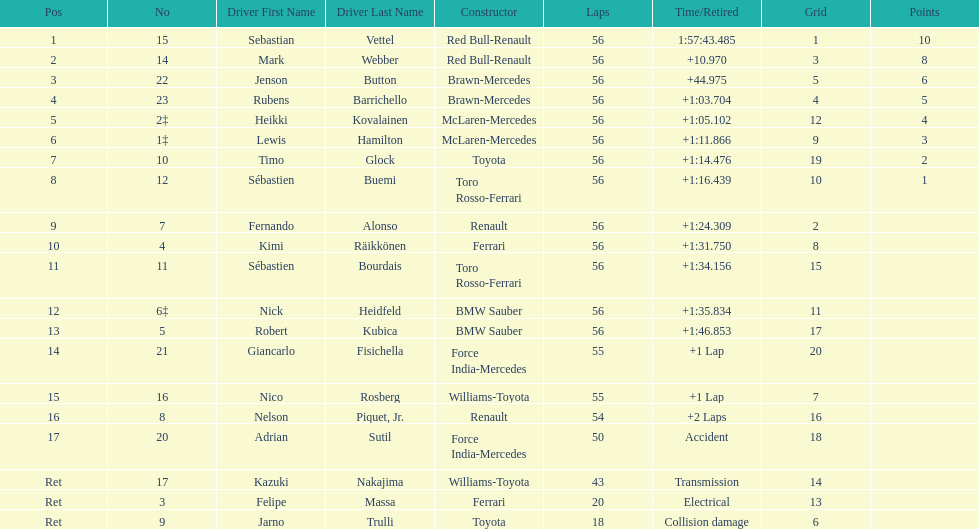What driver was last on the list? Jarno Trulli. Could you parse the entire table? {'header': ['Pos', 'No', 'Driver First Name', 'Driver Last Name', 'Constructor', 'Laps', 'Time/Retired', 'Grid', 'Points'], 'rows': [['1', '15', 'Sebastian', 'Vettel', 'Red Bull-Renault', '56', '1:57:43.485', '1', '10'], ['2', '14', 'Mark', 'Webber', 'Red Bull-Renault', '56', '+10.970', '3', '8'], ['3', '22', 'Jenson', 'Button', 'Brawn-Mercedes', '56', '+44.975', '5', '6'], ['4', '23', 'Rubens', 'Barrichello', 'Brawn-Mercedes', '56', '+1:03.704', '4', '5'], ['5', '2‡', 'Heikki', 'Kovalainen', 'McLaren-Mercedes', '56', '+1:05.102', '12', '4'], ['6', '1‡', 'Lewis', 'Hamilton', 'McLaren-Mercedes', '56', '+1:11.866', '9', '3'], ['7', '10', 'Timo', 'Glock', 'Toyota', '56', '+1:14.476', '19', '2'], ['8', '12', 'Sébastien', 'Buemi', 'Toro Rosso-Ferrari', '56', '+1:16.439', '10', '1'], ['9', '7', 'Fernando', 'Alonso', 'Renault', '56', '+1:24.309', '2', ''], ['10', '4', 'Kimi', 'Räikkönen', 'Ferrari', '56', '+1:31.750', '8', ''], ['11', '11', 'Sébastien', 'Bourdais', 'Toro Rosso-Ferrari', '56', '+1:34.156', '15', ''], ['12', '6‡', 'Nick', 'Heidfeld', 'BMW Sauber', '56', '+1:35.834', '11', ''], ['13', '5', 'Robert', 'Kubica', 'BMW Sauber', '56', '+1:46.853', '17', ''], ['14', '21', 'Giancarlo', 'Fisichella', 'Force India-Mercedes', '55', '+1 Lap', '20', ''], ['15', '16', 'Nico', 'Rosberg', 'Williams-Toyota', '55', '+1 Lap', '7', ''], ['16', '8', 'Nelson', 'Piquet, Jr.', 'Renault', '54', '+2 Laps', '16', ''], ['17', '20', 'Adrian', 'Sutil', 'Force India-Mercedes', '50', 'Accident', '18', ''], ['Ret', '17', 'Kazuki', 'Nakajima', 'Williams-Toyota', '43', 'Transmission', '14', ''], ['Ret', '3', 'Felipe', 'Massa', 'Ferrari', '20', 'Electrical', '13', ''], ['Ret', '9', 'Jarno', 'Trulli', 'Toyota', '18', 'Collision damage', '6', '']]} 